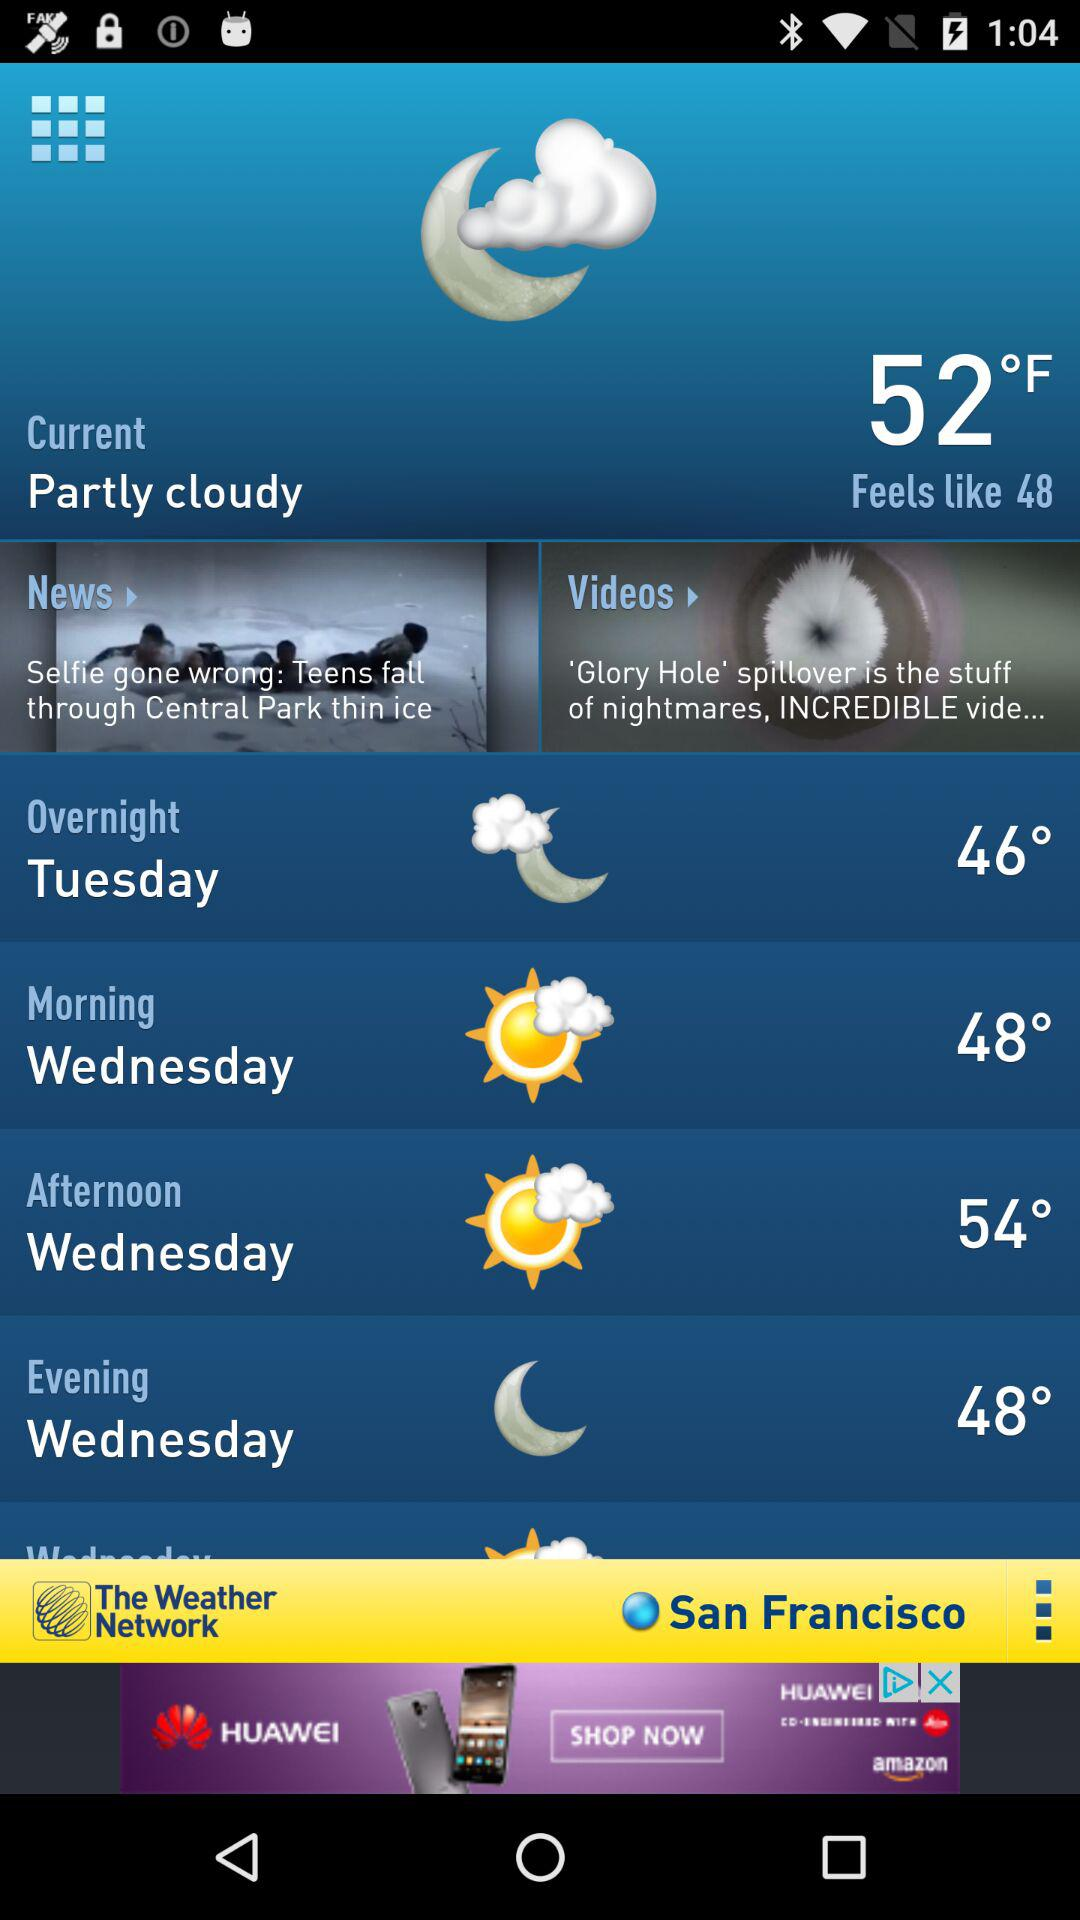What is the current weather? The current weather is partly cloudy. 